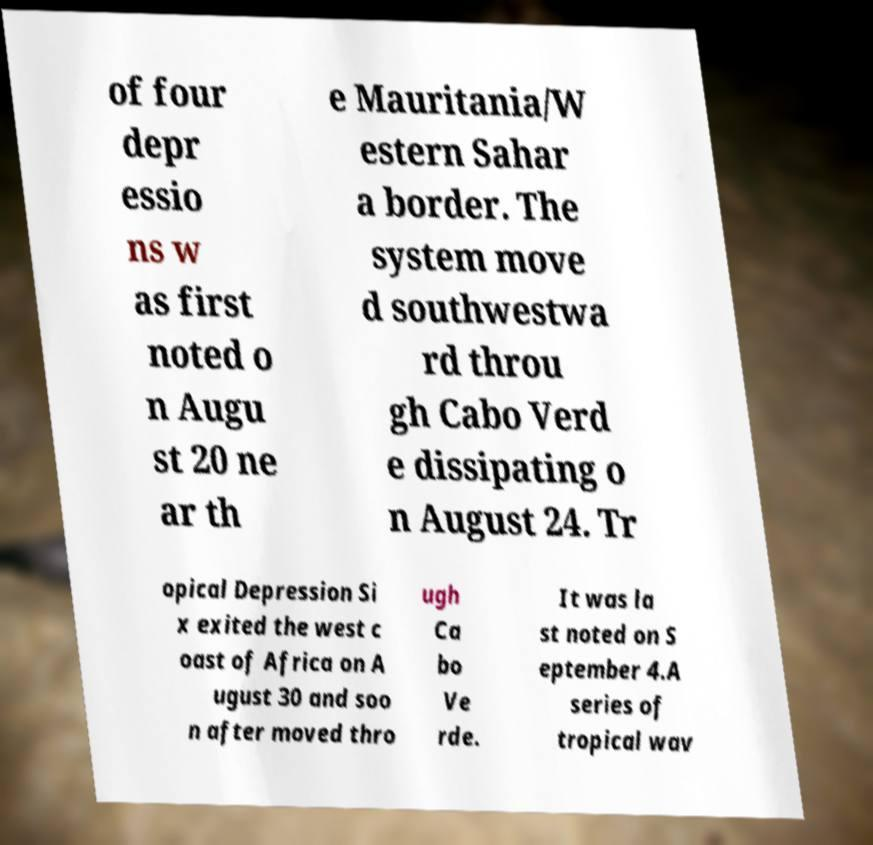There's text embedded in this image that I need extracted. Can you transcribe it verbatim? of four depr essio ns w as first noted o n Augu st 20 ne ar th e Mauritania/W estern Sahar a border. The system move d southwestwa rd throu gh Cabo Verd e dissipating o n August 24. Tr opical Depression Si x exited the west c oast of Africa on A ugust 30 and soo n after moved thro ugh Ca bo Ve rde. It was la st noted on S eptember 4.A series of tropical wav 